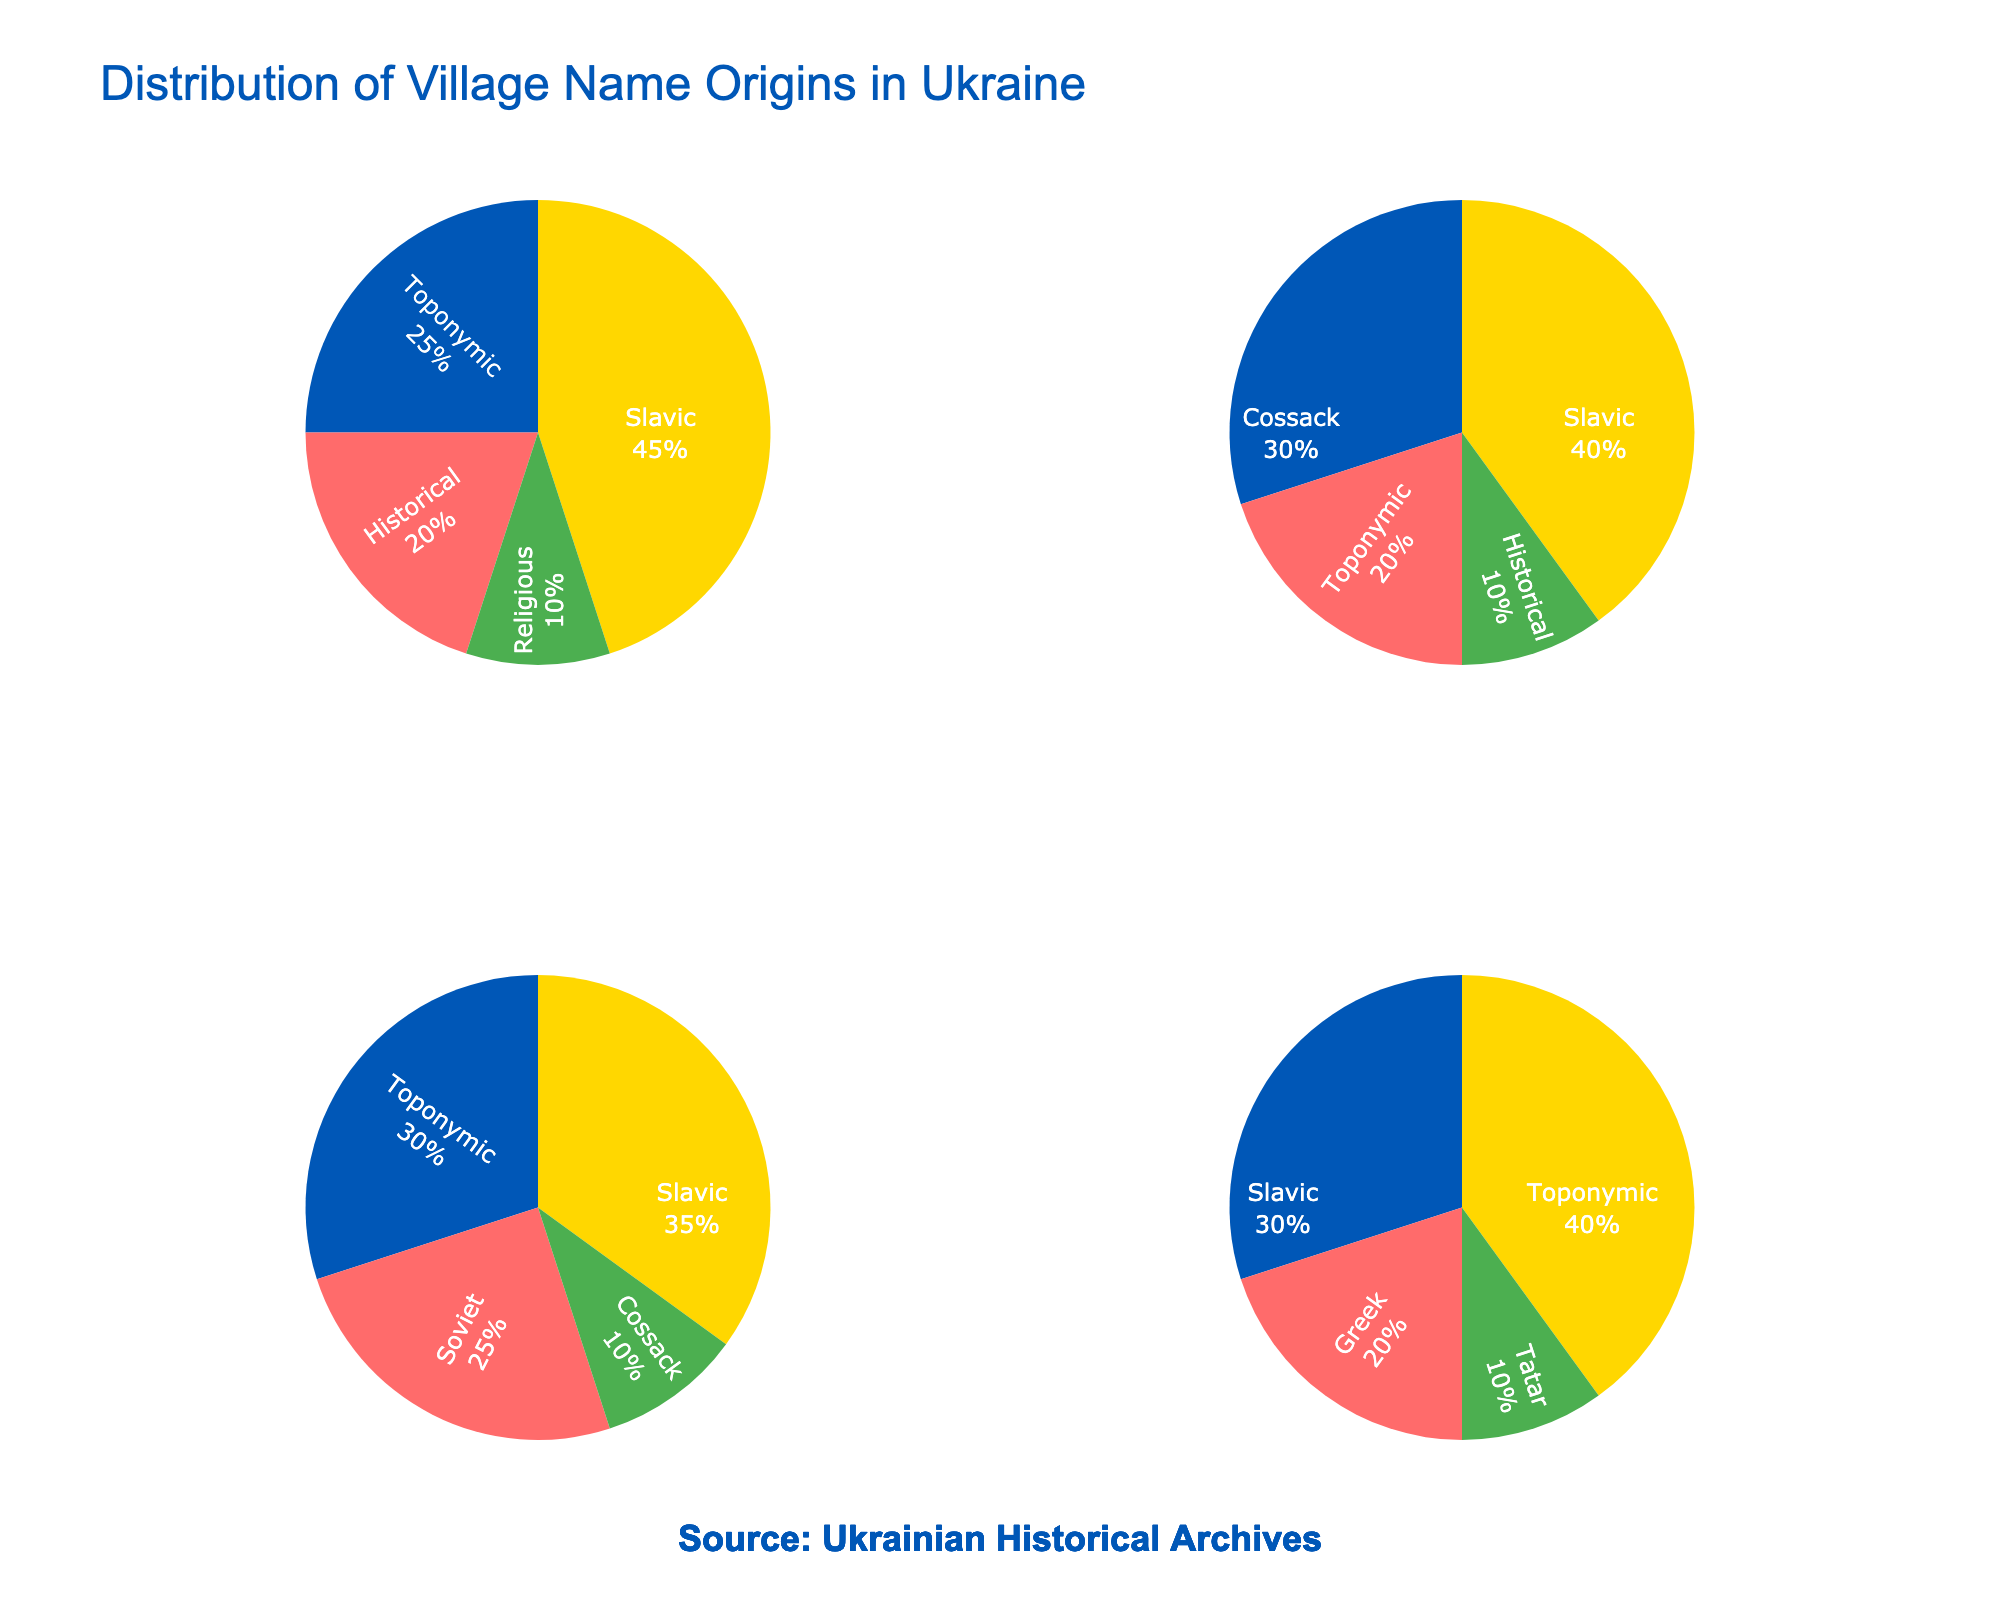what is the most common village name origin in Western Ukraine? The pie chart for Western Ukraine shows that the largest slice is labeled 'Slavic', with 45%. Therefore, the most common origin is Slavic.
Answer: Slavic Which region has the highest percentage of Cossack origin village names? To find this, we compare the 'Cossack' slice's percentage in the relevant regions. Central Ukraine has 30% while Eastern Ukraine has 10%. Central Ukraine has the highest percentage of Cossack origin village names.
Answer: Central Ukraine What percentage of village names in Southern Ukraine have a Greek origin? The Southern Ukraine pie chart shows a 'Greek' slice with a percentage label of 20%. Thus, 20% of village names in Southern Ukraine have a Greek origin.
Answer: 20% How does the percentage of Historical origins in Western Ukraine compare to that in Central Ukraine? In Western Ukraine, the percentage of Historical origins is 20%, while in Central Ukraine it is 10%. Therefore, Western Ukraine has a higher percentage of Historical origin village names than Central Ukraine.
Answer: Western Ukraine has a higher percentage What is the combined percentage of Toponymic village name origins in all regions? Sum the percentages of Toponymic origins: Western Ukraine (25%), Central Ukraine (20%), Eastern Ukraine (30%), Southern Ukraine (40%). Adding these gives 25% + 20% + 30% + 40% = 115%.
Answer: 115% Which region has the lowest percentage of Slavic origin village names? Comparing the Slavic percentages: Western Ukraine (45%), Central Ukraine (40%), Eastern Ukraine (35%), Southern Ukraine (30%). Southern Ukraine has the lowest percentage at 30%.
Answer: Southern Ukraine If you combine the percentage of Slavic and Toponymic origins in Eastern Ukraine, what is the total? Add the percentages of Slavic (35%) and Toponymic (30%) origins in Eastern Ukraine. 35% + 30% = 65%.
Answer: 65% What is the least common village name origin in Southern Ukraine? The pie chart for Southern Ukraine shows Tatar origin with a percentage of 10%, which is the smallest slice. Therefore, Tatar is the least common.
Answer: Tatar 